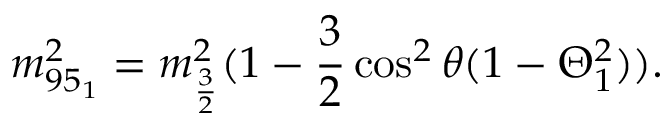Convert formula to latex. <formula><loc_0><loc_0><loc_500><loc_500>m _ { 9 5 _ { 1 } } ^ { 2 } = m _ { \frac { 3 } { 2 } } ^ { 2 } ( 1 - \frac { 3 } { 2 } \cos ^ { 2 } \theta ( 1 - \Theta _ { 1 } ^ { 2 } ) ) .</formula> 